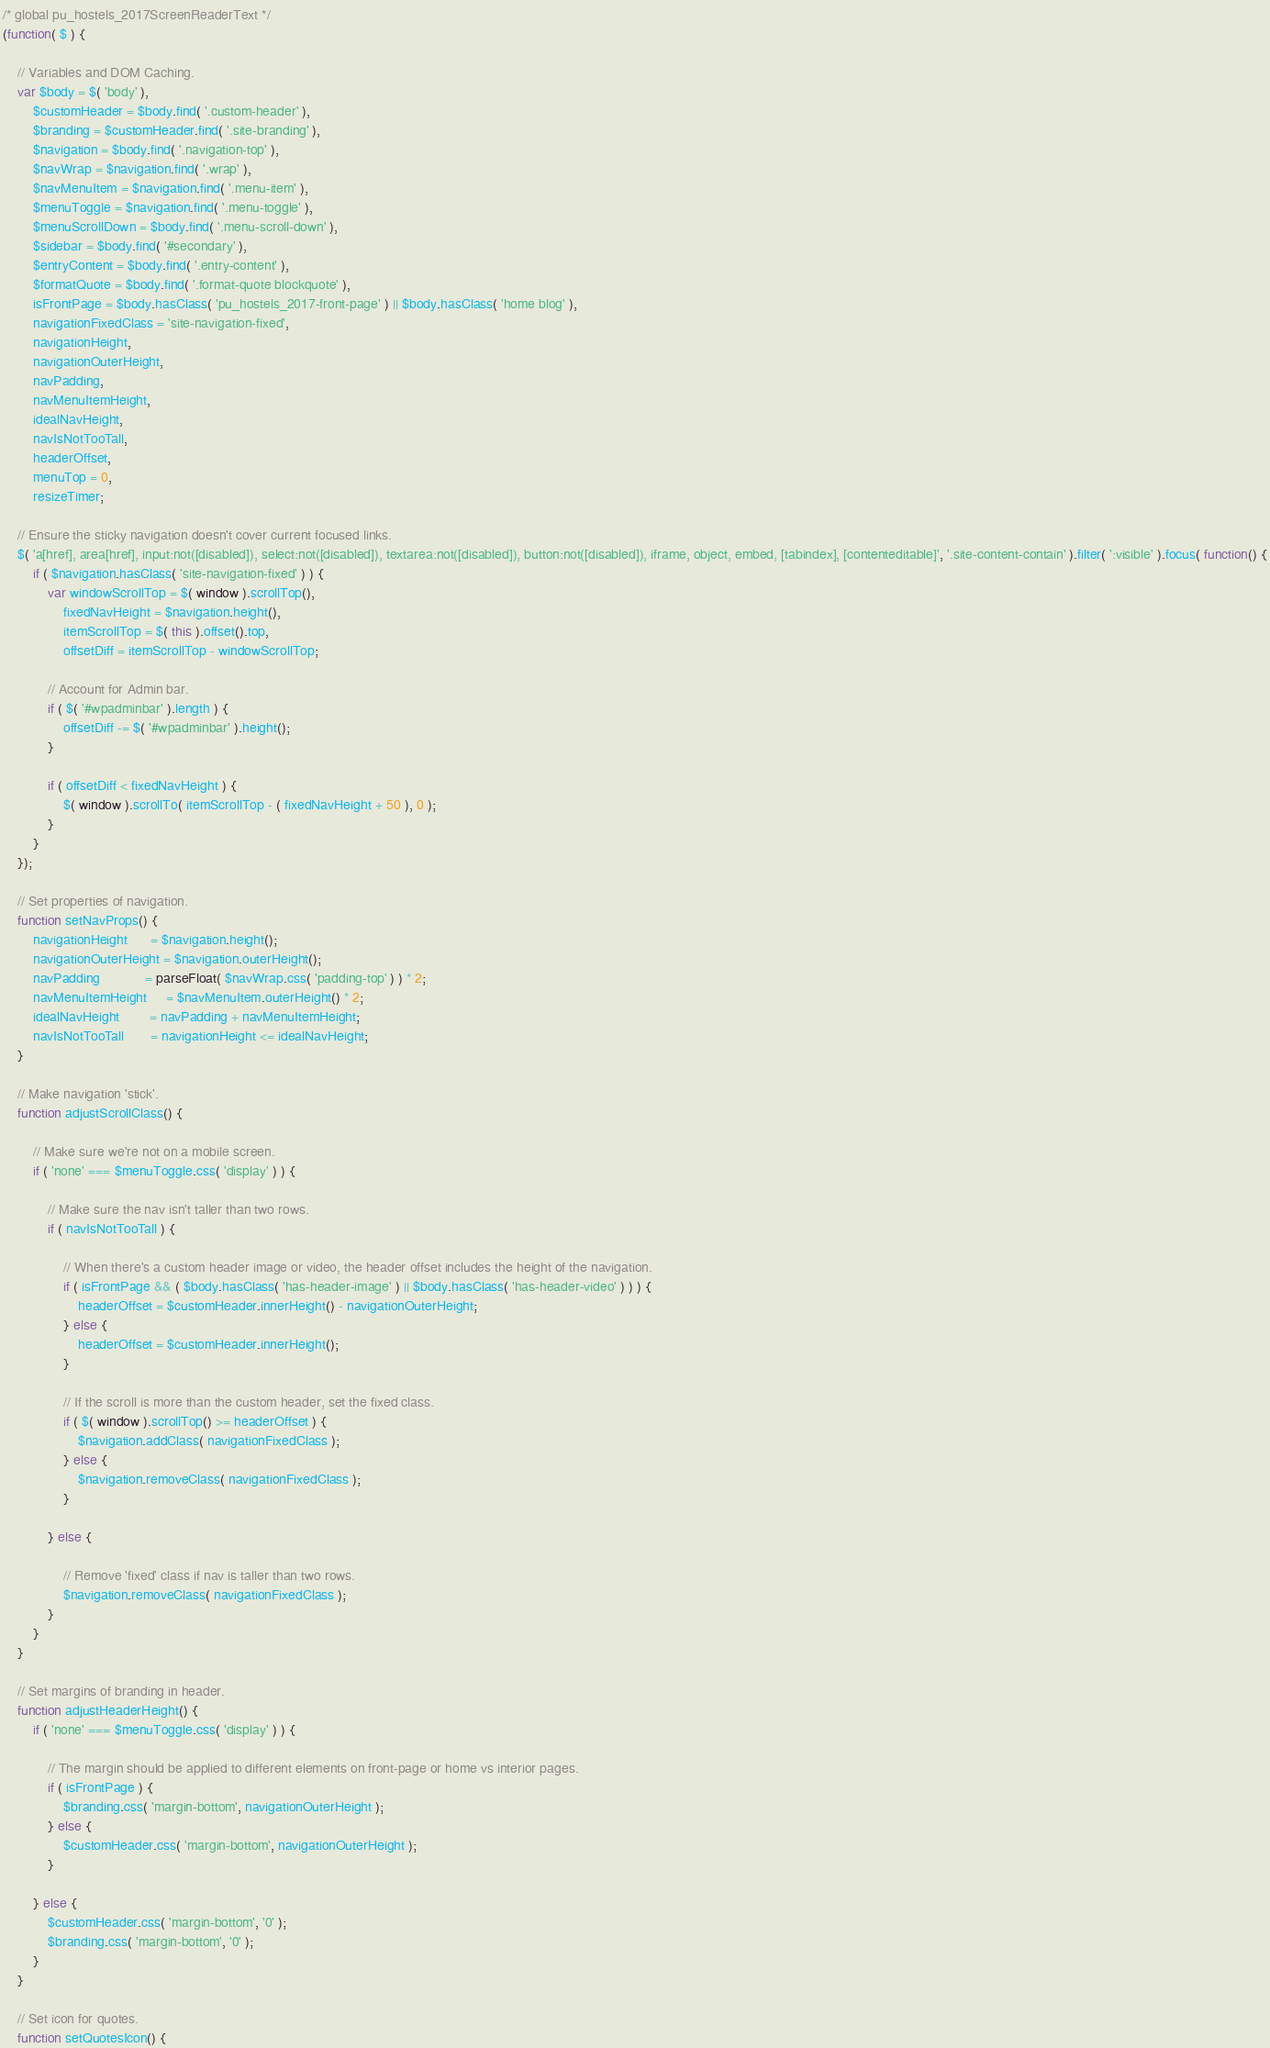Convert code to text. <code><loc_0><loc_0><loc_500><loc_500><_JavaScript_>/* global pu_hostels_2017ScreenReaderText */
(function( $ ) {

	// Variables and DOM Caching.
	var $body = $( 'body' ),
		$customHeader = $body.find( '.custom-header' ),
		$branding = $customHeader.find( '.site-branding' ),
		$navigation = $body.find( '.navigation-top' ),
		$navWrap = $navigation.find( '.wrap' ),
		$navMenuItem = $navigation.find( '.menu-item' ),
		$menuToggle = $navigation.find( '.menu-toggle' ),
		$menuScrollDown = $body.find( '.menu-scroll-down' ),
		$sidebar = $body.find( '#secondary' ),
		$entryContent = $body.find( '.entry-content' ),
		$formatQuote = $body.find( '.format-quote blockquote' ),
		isFrontPage = $body.hasClass( 'pu_hostels_2017-front-page' ) || $body.hasClass( 'home blog' ),
		navigationFixedClass = 'site-navigation-fixed',
		navigationHeight,
		navigationOuterHeight,
		navPadding,
		navMenuItemHeight,
		idealNavHeight,
		navIsNotTooTall,
		headerOffset,
		menuTop = 0,
		resizeTimer;

	// Ensure the sticky navigation doesn't cover current focused links.
	$( 'a[href], area[href], input:not([disabled]), select:not([disabled]), textarea:not([disabled]), button:not([disabled]), iframe, object, embed, [tabindex], [contenteditable]', '.site-content-contain' ).filter( ':visible' ).focus( function() {
		if ( $navigation.hasClass( 'site-navigation-fixed' ) ) {
			var windowScrollTop = $( window ).scrollTop(),
				fixedNavHeight = $navigation.height(),
				itemScrollTop = $( this ).offset().top,
				offsetDiff = itemScrollTop - windowScrollTop;

			// Account for Admin bar.
			if ( $( '#wpadminbar' ).length ) {
				offsetDiff -= $( '#wpadminbar' ).height();
			}

			if ( offsetDiff < fixedNavHeight ) {
				$( window ).scrollTo( itemScrollTop - ( fixedNavHeight + 50 ), 0 );
			}
		}
	});

	// Set properties of navigation.
	function setNavProps() {
		navigationHeight      = $navigation.height();
		navigationOuterHeight = $navigation.outerHeight();
		navPadding            = parseFloat( $navWrap.css( 'padding-top' ) ) * 2;
		navMenuItemHeight     = $navMenuItem.outerHeight() * 2;
		idealNavHeight        = navPadding + navMenuItemHeight;
		navIsNotTooTall       = navigationHeight <= idealNavHeight;
	}

	// Make navigation 'stick'.
	function adjustScrollClass() {

		// Make sure we're not on a mobile screen.
		if ( 'none' === $menuToggle.css( 'display' ) ) {

			// Make sure the nav isn't taller than two rows.
			if ( navIsNotTooTall ) {

				// When there's a custom header image or video, the header offset includes the height of the navigation.
				if ( isFrontPage && ( $body.hasClass( 'has-header-image' ) || $body.hasClass( 'has-header-video' ) ) ) {
					headerOffset = $customHeader.innerHeight() - navigationOuterHeight;
				} else {
					headerOffset = $customHeader.innerHeight();
				}

				// If the scroll is more than the custom header, set the fixed class.
				if ( $( window ).scrollTop() >= headerOffset ) {
					$navigation.addClass( navigationFixedClass );
				} else {
					$navigation.removeClass( navigationFixedClass );
				}

			} else {

				// Remove 'fixed' class if nav is taller than two rows.
				$navigation.removeClass( navigationFixedClass );
			}
		}
	}

	// Set margins of branding in header.
	function adjustHeaderHeight() {
		if ( 'none' === $menuToggle.css( 'display' ) ) {

			// The margin should be applied to different elements on front-page or home vs interior pages.
			if ( isFrontPage ) {
				$branding.css( 'margin-bottom', navigationOuterHeight );
			} else {
				$customHeader.css( 'margin-bottom', navigationOuterHeight );
			}

		} else {
			$customHeader.css( 'margin-bottom', '0' );
			$branding.css( 'margin-bottom', '0' );
		}
	}

	// Set icon for quotes.
	function setQuotesIcon() {</code> 